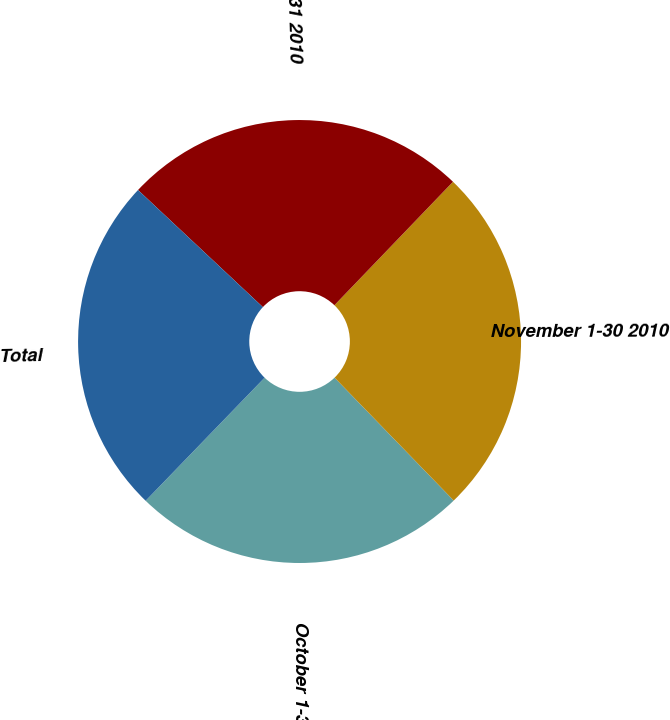Convert chart to OTSL. <chart><loc_0><loc_0><loc_500><loc_500><pie_chart><fcel>October 1-31 2010<fcel>November 1-30 2010<fcel>December 1-31 2010<fcel>Total<nl><fcel>24.48%<fcel>25.57%<fcel>25.19%<fcel>24.76%<nl></chart> 